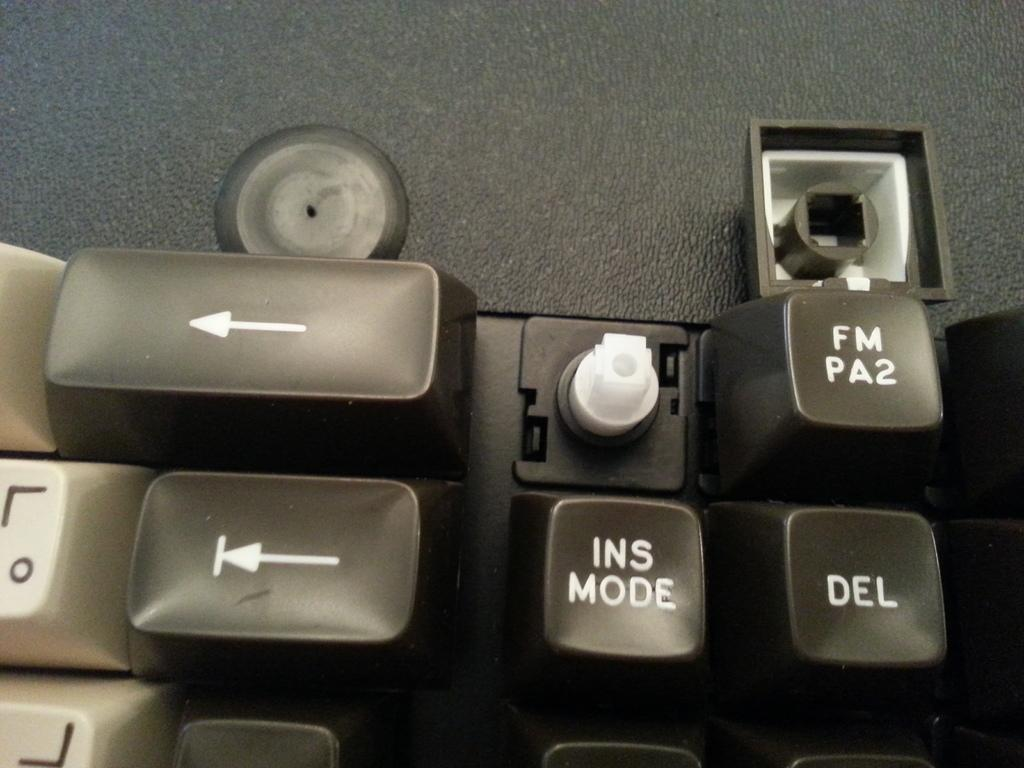<image>
Summarize the visual content of the image. A close up of a keyboard and a key is broken above the INS MODE key. 